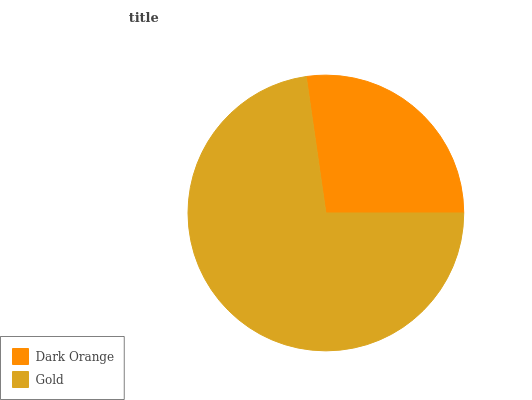Is Dark Orange the minimum?
Answer yes or no. Yes. Is Gold the maximum?
Answer yes or no. Yes. Is Gold the minimum?
Answer yes or no. No. Is Gold greater than Dark Orange?
Answer yes or no. Yes. Is Dark Orange less than Gold?
Answer yes or no. Yes. Is Dark Orange greater than Gold?
Answer yes or no. No. Is Gold less than Dark Orange?
Answer yes or no. No. Is Gold the high median?
Answer yes or no. Yes. Is Dark Orange the low median?
Answer yes or no. Yes. Is Dark Orange the high median?
Answer yes or no. No. Is Gold the low median?
Answer yes or no. No. 